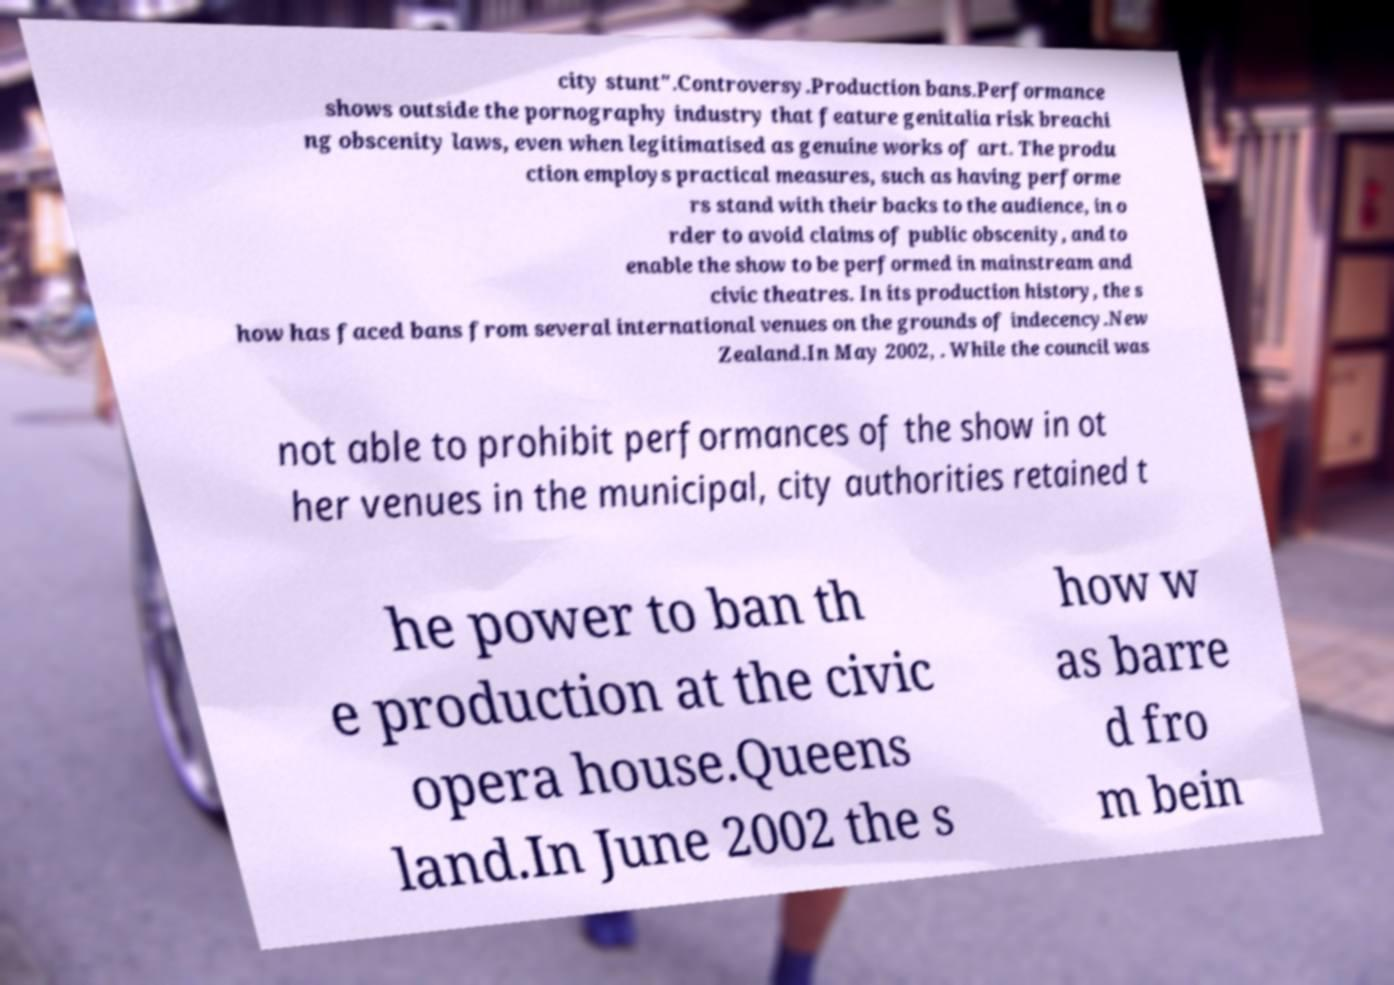For documentation purposes, I need the text within this image transcribed. Could you provide that? city stunt".Controversy.Production bans.Performance shows outside the pornography industry that feature genitalia risk breachi ng obscenity laws, even when legitimatised as genuine works of art. The produ ction employs practical measures, such as having performe rs stand with their backs to the audience, in o rder to avoid claims of public obscenity, and to enable the show to be performed in mainstream and civic theatres. In its production history, the s how has faced bans from several international venues on the grounds of indecency.New Zealand.In May 2002, . While the council was not able to prohibit performances of the show in ot her venues in the municipal, city authorities retained t he power to ban th e production at the civic opera house.Queens land.In June 2002 the s how w as barre d fro m bein 